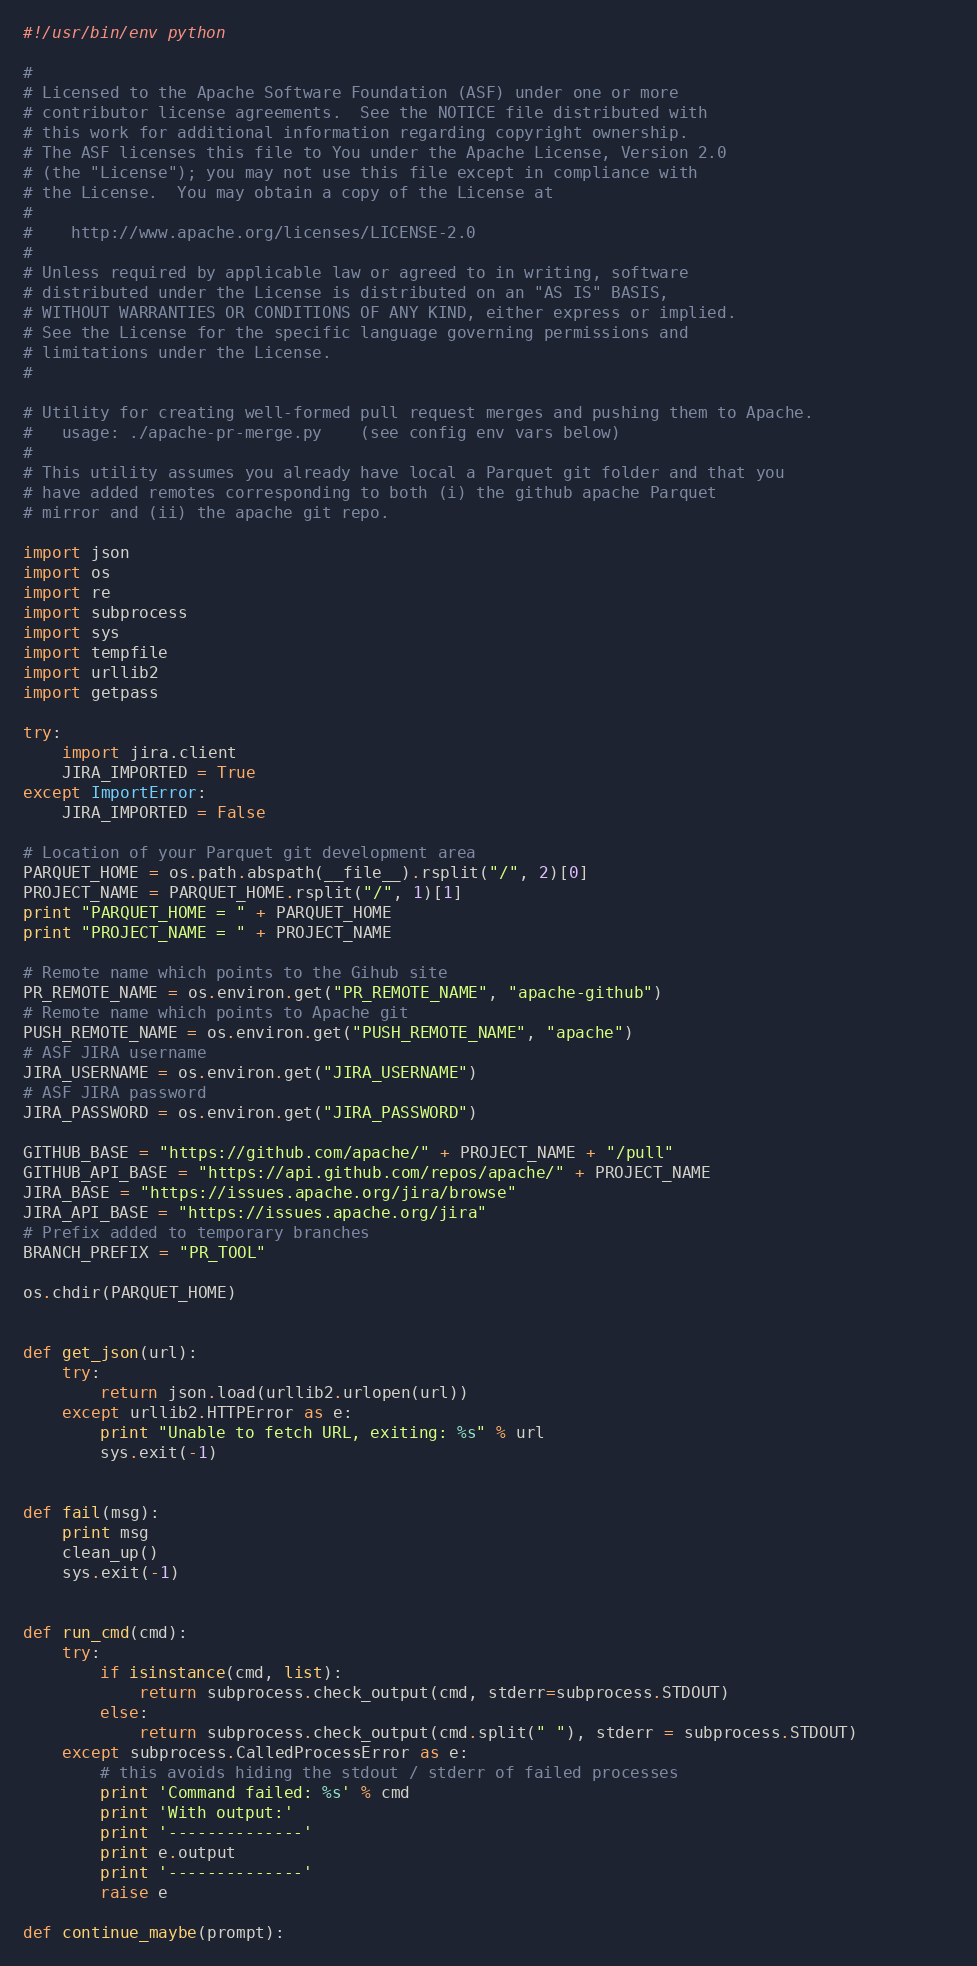<code> <loc_0><loc_0><loc_500><loc_500><_Python_>#!/usr/bin/env python

#
# Licensed to the Apache Software Foundation (ASF) under one or more
# contributor license agreements.  See the NOTICE file distributed with
# this work for additional information regarding copyright ownership.
# The ASF licenses this file to You under the Apache License, Version 2.0
# (the "License"); you may not use this file except in compliance with
# the License.  You may obtain a copy of the License at
#
#    http://www.apache.org/licenses/LICENSE-2.0
#
# Unless required by applicable law or agreed to in writing, software
# distributed under the License is distributed on an "AS IS" BASIS,
# WITHOUT WARRANTIES OR CONDITIONS OF ANY KIND, either express or implied.
# See the License for the specific language governing permissions and
# limitations under the License.
#

# Utility for creating well-formed pull request merges and pushing them to Apache.
#   usage: ./apache-pr-merge.py    (see config env vars below)
#
# This utility assumes you already have local a Parquet git folder and that you
# have added remotes corresponding to both (i) the github apache Parquet
# mirror and (ii) the apache git repo.

import json
import os
import re
import subprocess
import sys
import tempfile
import urllib2
import getpass

try:
    import jira.client
    JIRA_IMPORTED = True
except ImportError:
    JIRA_IMPORTED = False

# Location of your Parquet git development area
PARQUET_HOME = os.path.abspath(__file__).rsplit("/", 2)[0]
PROJECT_NAME = PARQUET_HOME.rsplit("/", 1)[1]
print "PARQUET_HOME = " + PARQUET_HOME
print "PROJECT_NAME = " + PROJECT_NAME

# Remote name which points to the Gihub site
PR_REMOTE_NAME = os.environ.get("PR_REMOTE_NAME", "apache-github")
# Remote name which points to Apache git
PUSH_REMOTE_NAME = os.environ.get("PUSH_REMOTE_NAME", "apache")
# ASF JIRA username
JIRA_USERNAME = os.environ.get("JIRA_USERNAME")
# ASF JIRA password
JIRA_PASSWORD = os.environ.get("JIRA_PASSWORD")

GITHUB_BASE = "https://github.com/apache/" + PROJECT_NAME + "/pull"
GITHUB_API_BASE = "https://api.github.com/repos/apache/" + PROJECT_NAME
JIRA_BASE = "https://issues.apache.org/jira/browse"
JIRA_API_BASE = "https://issues.apache.org/jira"
# Prefix added to temporary branches
BRANCH_PREFIX = "PR_TOOL"

os.chdir(PARQUET_HOME)


def get_json(url):
    try:
        return json.load(urllib2.urlopen(url))
    except urllib2.HTTPError as e:
        print "Unable to fetch URL, exiting: %s" % url
        sys.exit(-1)


def fail(msg):
    print msg
    clean_up()
    sys.exit(-1)


def run_cmd(cmd):
    try:       
        if isinstance(cmd, list):
            return subprocess.check_output(cmd, stderr=subprocess.STDOUT)
        else:
            return subprocess.check_output(cmd.split(" "), stderr = subprocess.STDOUT)          
    except subprocess.CalledProcessError as e:
        # this avoids hiding the stdout / stderr of failed processes
        print 'Command failed: %s' % cmd
        print 'With output:'
        print '--------------'
        print e.output
        print '--------------'
        raise e

def continue_maybe(prompt):</code> 